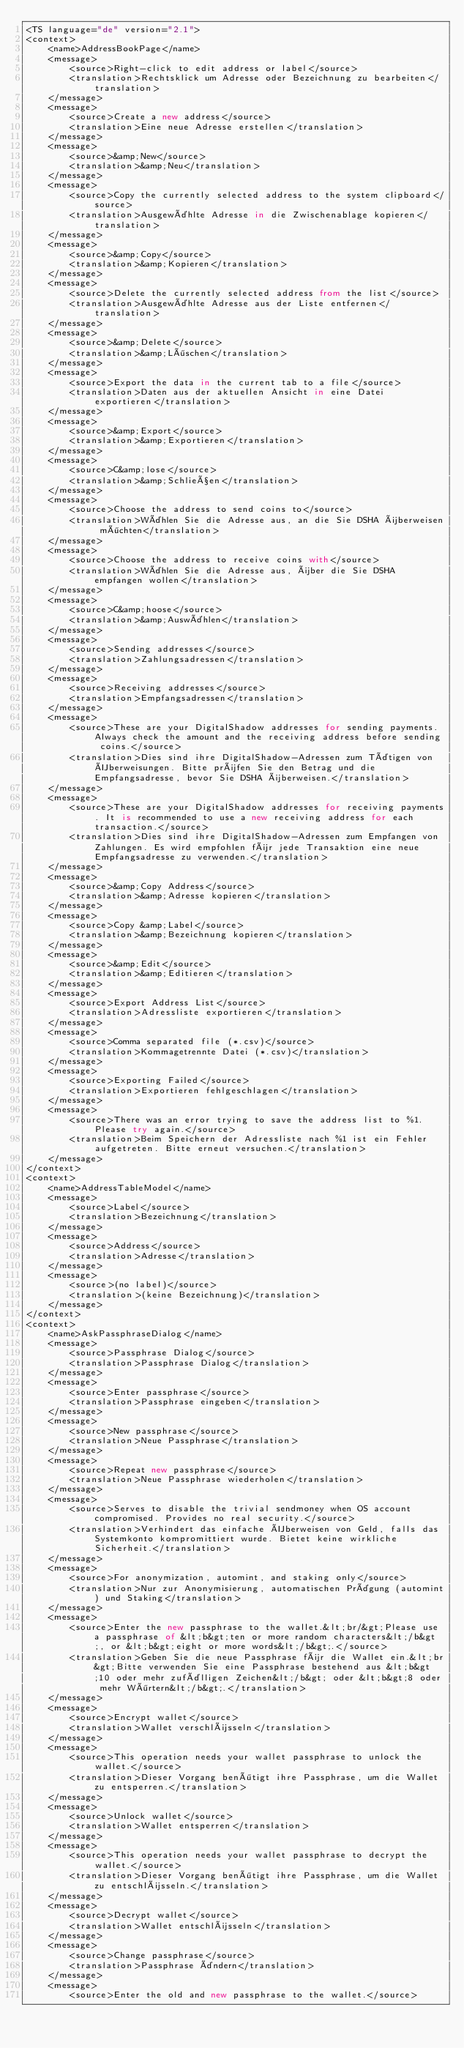Convert code to text. <code><loc_0><loc_0><loc_500><loc_500><_TypeScript_><TS language="de" version="2.1">
<context>
    <name>AddressBookPage</name>
    <message>
        <source>Right-click to edit address or label</source>
        <translation>Rechtsklick um Adresse oder Bezeichnung zu bearbeiten</translation>
    </message>
    <message>
        <source>Create a new address</source>
        <translation>Eine neue Adresse erstellen</translation>
    </message>
    <message>
        <source>&amp;New</source>
        <translation>&amp;Neu</translation>
    </message>
    <message>
        <source>Copy the currently selected address to the system clipboard</source>
        <translation>Ausgewählte Adresse in die Zwischenablage kopieren</translation>
    </message>
    <message>
        <source>&amp;Copy</source>
        <translation>&amp;Kopieren</translation>
    </message>
    <message>
        <source>Delete the currently selected address from the list</source>
        <translation>Ausgewählte Adresse aus der Liste entfernen</translation>
    </message>
    <message>
        <source>&amp;Delete</source>
        <translation>&amp;Löschen</translation>
    </message>
    <message>
        <source>Export the data in the current tab to a file</source>
        <translation>Daten aus der aktuellen Ansicht in eine Datei exportieren</translation>
    </message>
    <message>
        <source>&amp;Export</source>
        <translation>&amp;Exportieren</translation>
    </message>
    <message>
        <source>C&amp;lose</source>
        <translation>&amp;Schließen</translation>
    </message>
    <message>
        <source>Choose the address to send coins to</source>
        <translation>Wählen Sie die Adresse aus, an die Sie DSHA überweisen möchten</translation>
    </message>
    <message>
        <source>Choose the address to receive coins with</source>
        <translation>Wählen Sie die Adresse aus, über die Sie DSHA empfangen wollen</translation>
    </message>
    <message>
        <source>C&amp;hoose</source>
        <translation>&amp;Auswählen</translation>
    </message>
    <message>
        <source>Sending addresses</source>
        <translation>Zahlungsadressen</translation>
    </message>
    <message>
        <source>Receiving addresses</source>
        <translation>Empfangsadressen</translation>
    </message>
    <message>
        <source>These are your DigitalShadow addresses for sending payments. Always check the amount and the receiving address before sending coins.</source>
        <translation>Dies sind ihre DigitalShadow-Adressen zum Tätigen von Überweisungen. Bitte prüfen Sie den Betrag und die Empfangsadresse, bevor Sie DSHA überweisen.</translation>
    </message>
    <message>
        <source>These are your DigitalShadow addresses for receiving payments. It is recommended to use a new receiving address for each transaction.</source>
        <translation>Dies sind ihre DigitalShadow-Adressen zum Empfangen von Zahlungen. Es wird empfohlen für jede Transaktion eine neue Empfangsadresse zu verwenden.</translation>
    </message>
    <message>
        <source>&amp;Copy Address</source>
        <translation>&amp;Adresse kopieren</translation>
    </message>
    <message>
        <source>Copy &amp;Label</source>
        <translation>&amp;Bezeichnung kopieren</translation>
    </message>
    <message>
        <source>&amp;Edit</source>
        <translation>&amp;Editieren</translation>
    </message>
    <message>
        <source>Export Address List</source>
        <translation>Adressliste exportieren</translation>
    </message>
    <message>
        <source>Comma separated file (*.csv)</source>
        <translation>Kommagetrennte Datei (*.csv)</translation>
    </message>
    <message>
        <source>Exporting Failed</source>
        <translation>Exportieren fehlgeschlagen</translation>
    </message>
    <message>
        <source>There was an error trying to save the address list to %1. Please try again.</source>
        <translation>Beim Speichern der Adressliste nach %1 ist ein Fehler aufgetreten. Bitte erneut versuchen.</translation>
    </message>
</context>
<context>
    <name>AddressTableModel</name>
    <message>
        <source>Label</source>
        <translation>Bezeichnung</translation>
    </message>
    <message>
        <source>Address</source>
        <translation>Adresse</translation>
    </message>
    <message>
        <source>(no label)</source>
        <translation>(keine Bezeichnung)</translation>
    </message>
</context>
<context>
    <name>AskPassphraseDialog</name>
    <message>
        <source>Passphrase Dialog</source>
        <translation>Passphrase Dialog</translation>
    </message>
    <message>
        <source>Enter passphrase</source>
        <translation>Passphrase eingeben</translation>
    </message>
    <message>
        <source>New passphrase</source>
        <translation>Neue Passphrase</translation>
    </message>
    <message>
        <source>Repeat new passphrase</source>
        <translation>Neue Passphrase wiederholen</translation>
    </message>
    <message>
        <source>Serves to disable the trivial sendmoney when OS account compromised. Provides no real security.</source>
        <translation>Verhindert das einfache Überweisen von Geld, falls das Systemkonto kompromittiert wurde. Bietet keine wirkliche Sicherheit.</translation>
    </message>
    <message>
        <source>For anonymization, automint, and staking only</source>
        <translation>Nur zur Anonymisierung, automatischen Prägung (automint) und Staking</translation>
    </message>
    <message>
        <source>Enter the new passphrase to the wallet.&lt;br/&gt;Please use a passphrase of &lt;b&gt;ten or more random characters&lt;/b&gt;, or &lt;b&gt;eight or more words&lt;/b&gt;.</source>
        <translation>Geben Sie die neue Passphrase für die Wallet ein.&lt;br&gt;Bitte verwenden Sie eine Passphrase bestehend aus &lt;b&gt;10 oder mehr zufälligen Zeichen&lt;/b&gt; oder &lt;b&gt;8 oder mehr Wörtern&lt;/b&gt;.</translation>
    </message>
    <message>
        <source>Encrypt wallet</source>
        <translation>Wallet verschlüsseln</translation>
    </message>
    <message>
        <source>This operation needs your wallet passphrase to unlock the wallet.</source>
        <translation>Dieser Vorgang benötigt ihre Passphrase, um die Wallet zu entsperren.</translation>
    </message>
    <message>
        <source>Unlock wallet</source>
        <translation>Wallet entsperren</translation>
    </message>
    <message>
        <source>This operation needs your wallet passphrase to decrypt the wallet.</source>
        <translation>Dieser Vorgang benötigt ihre Passphrase, um die Wallet zu entschlüsseln.</translation>
    </message>
    <message>
        <source>Decrypt wallet</source>
        <translation>Wallet entschlüsseln</translation>
    </message>
    <message>
        <source>Change passphrase</source>
        <translation>Passphrase ändern</translation>
    </message>
    <message>
        <source>Enter the old and new passphrase to the wallet.</source></code> 